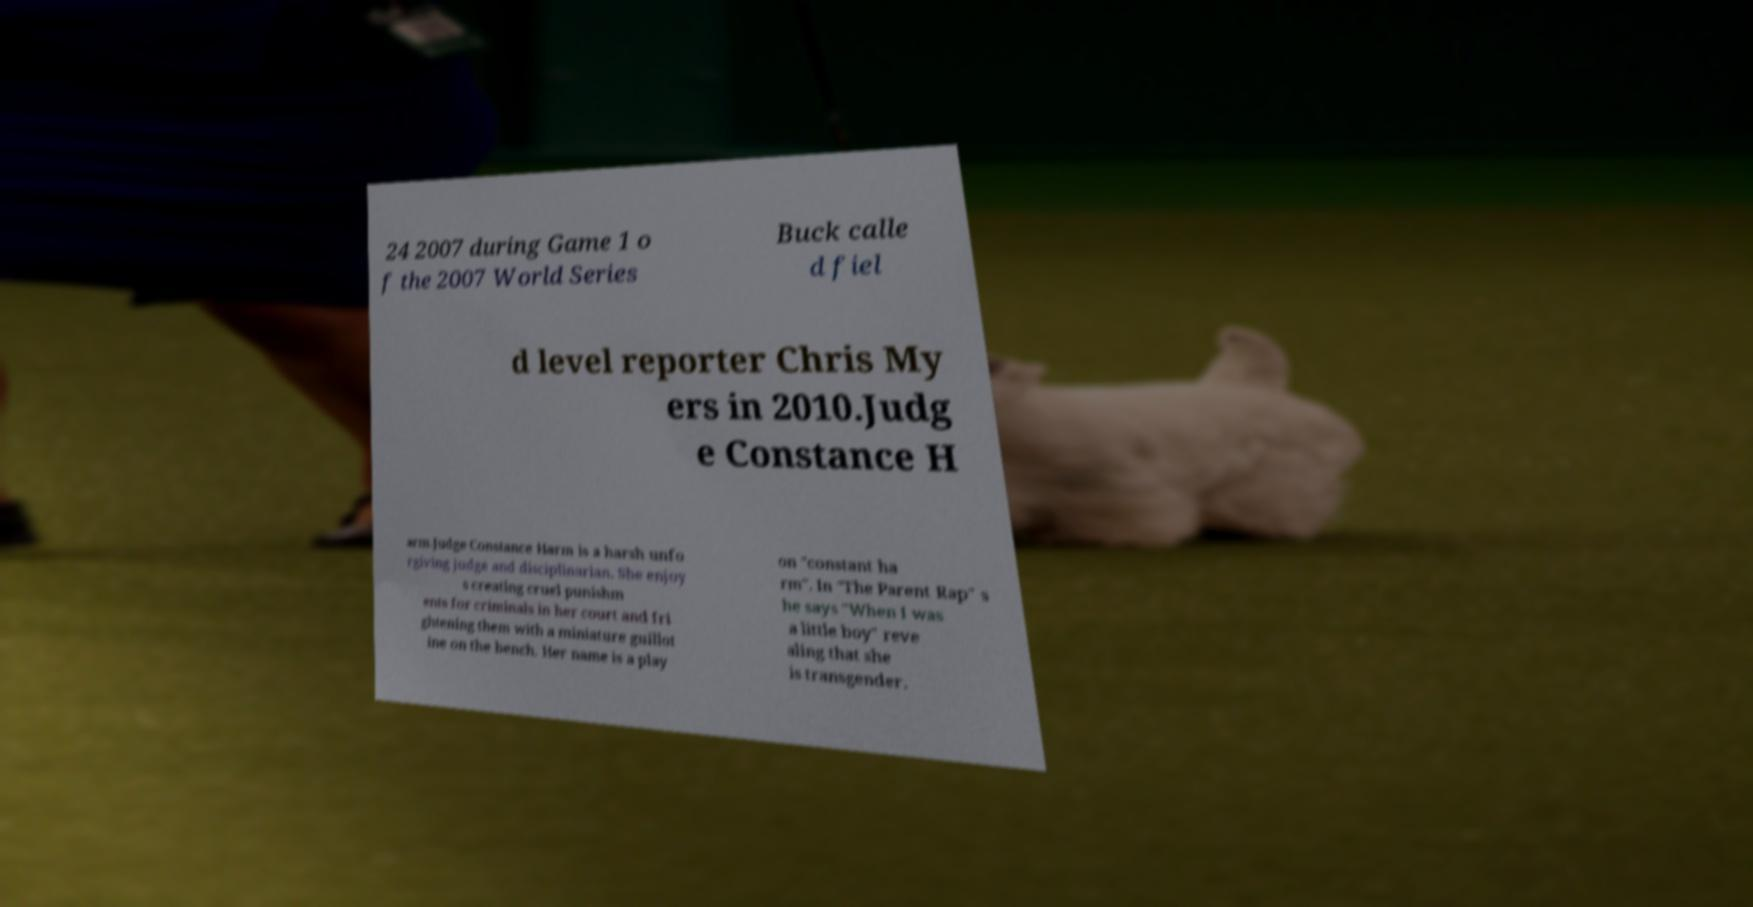Please identify and transcribe the text found in this image. 24 2007 during Game 1 o f the 2007 World Series Buck calle d fiel d level reporter Chris My ers in 2010.Judg e Constance H arm.Judge Constance Harm is a harsh unfo rgiving judge and disciplinarian. She enjoy s creating cruel punishm ents for criminals in her court and fri ghtening them with a miniature guillot ine on the bench. Her name is a play on "constant ha rm". In "The Parent Rap" s he says "When I was a little boy" reve aling that she is transgender. 